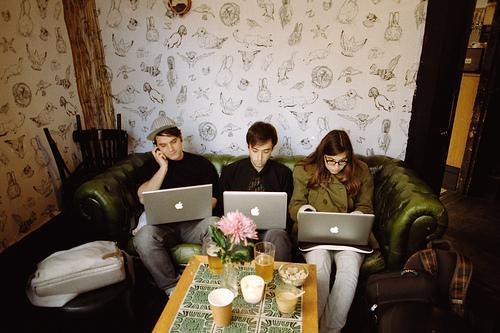How many people are in the picture?
Give a very brief answer. 3. How many women are in the picture?
Give a very brief answer. 1. 